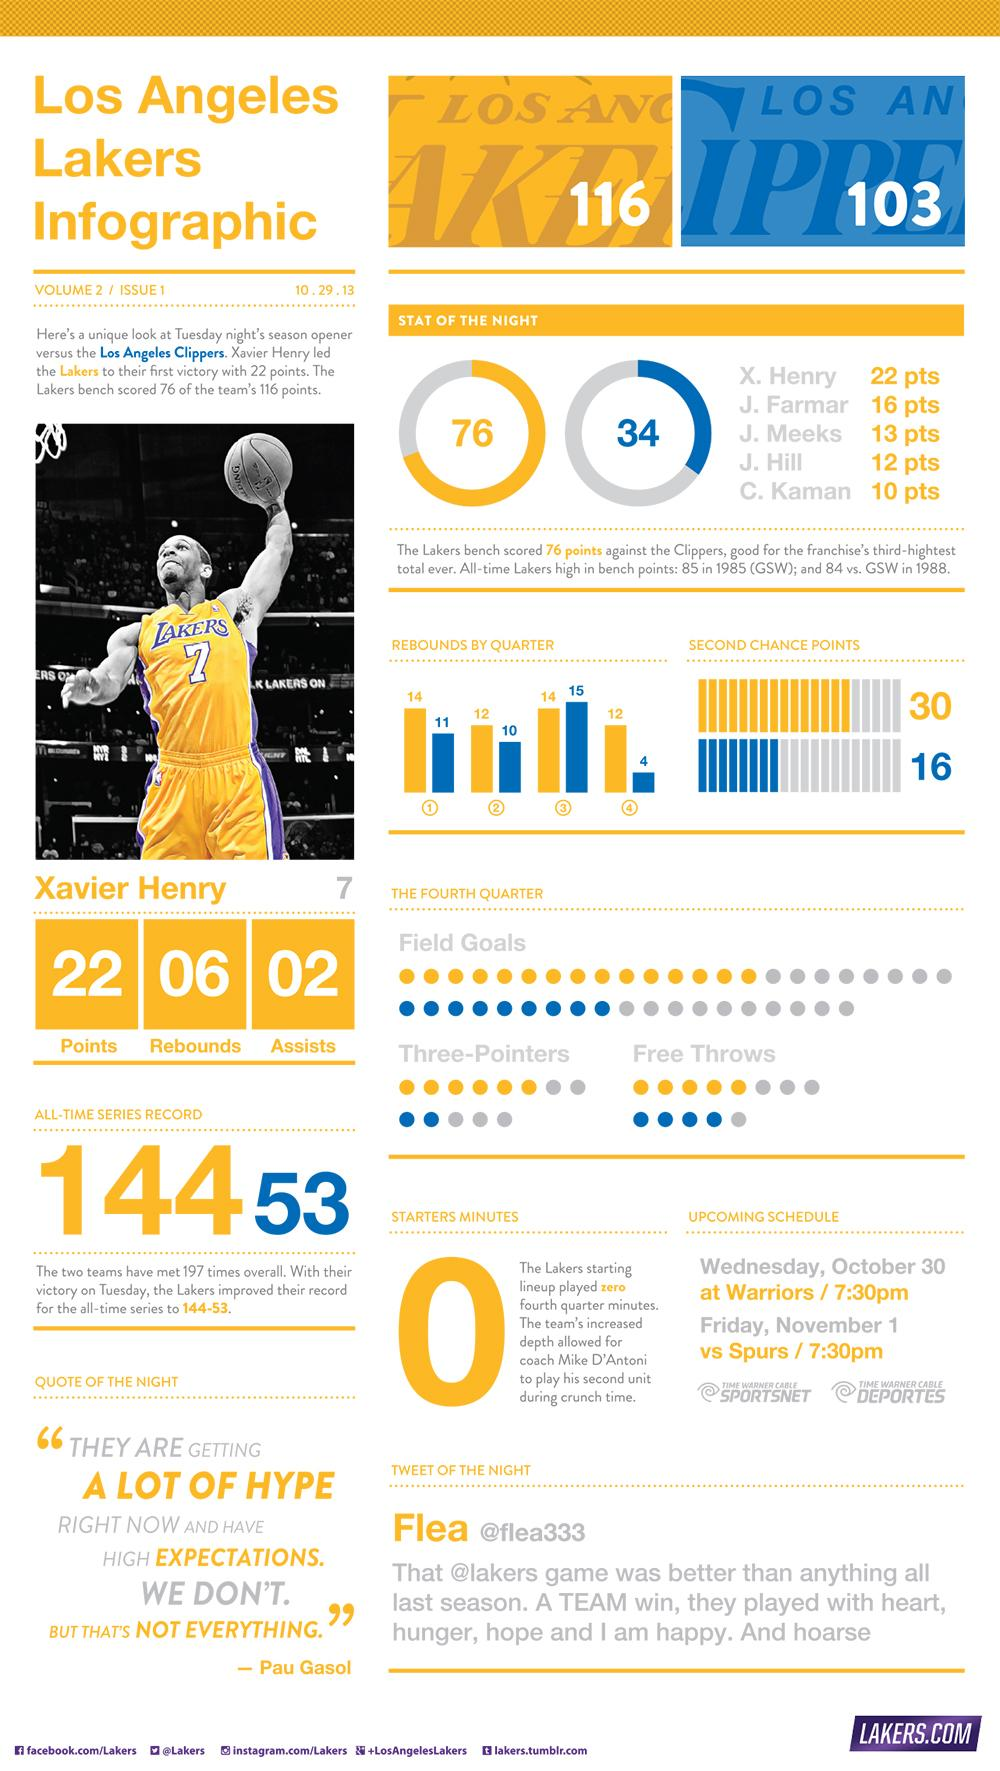List a handful of essential elements in this visual. There were four Lakers team players who scored more than ten points. The Los Angeles Lakers scored 30 second chance points in their game, demonstrating their ability to capitalize on opportunities and secure victory. The Los Angeles Clippers scored 16 second chance points in their game. The Los Angeles Clippers received a total of 103 points during the game. The Los Angeles Clippers had 10 rebounds in the second quarter. 